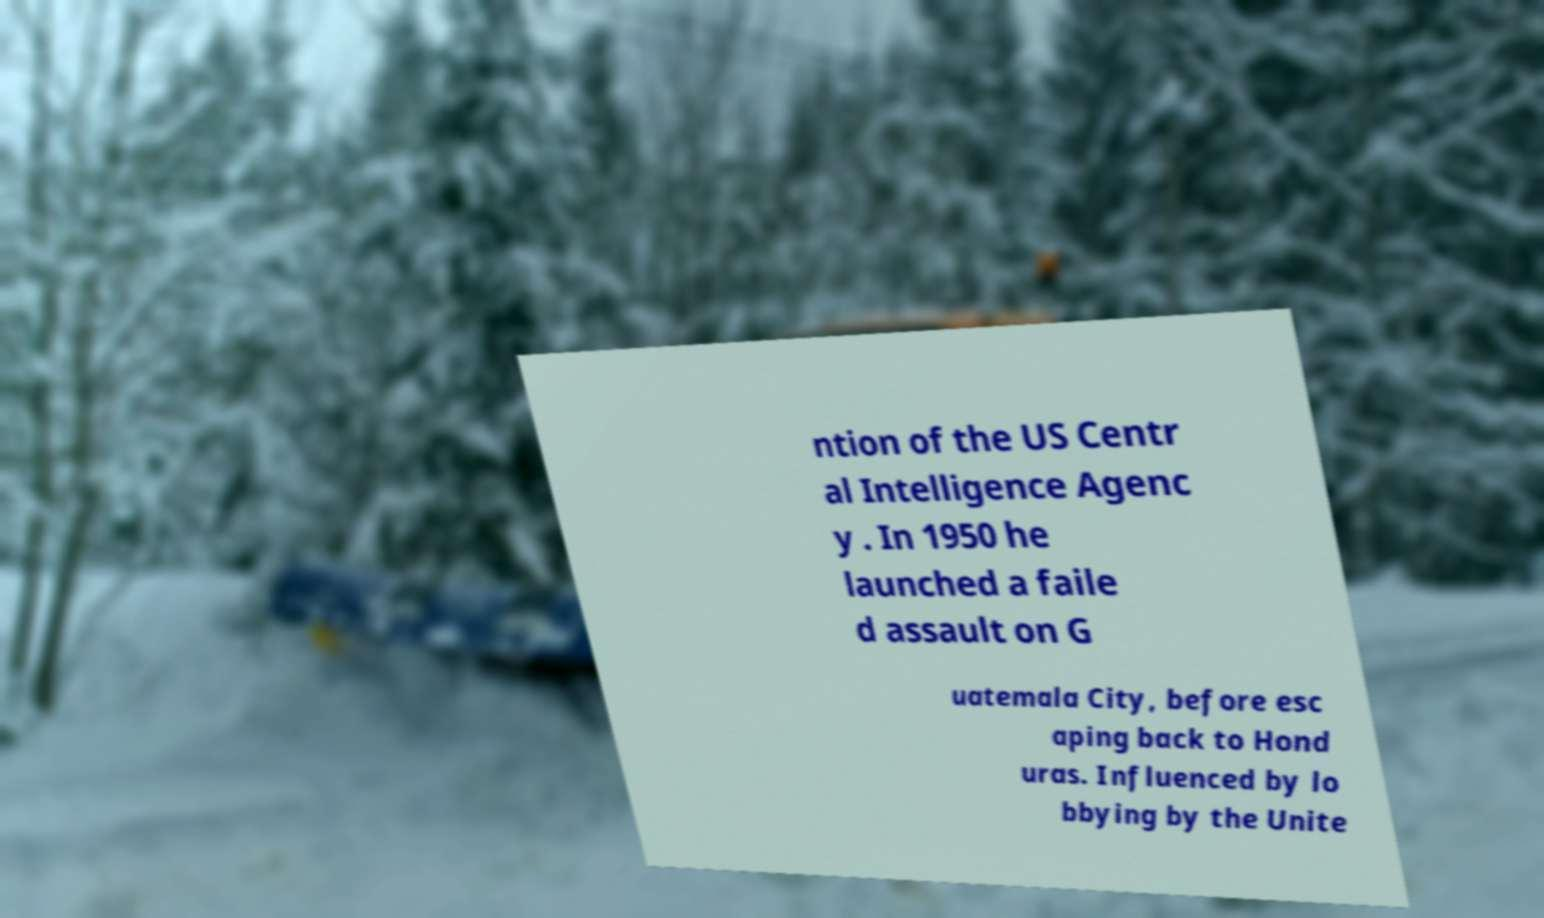What messages or text are displayed in this image? I need them in a readable, typed format. ntion of the US Centr al Intelligence Agenc y . In 1950 he launched a faile d assault on G uatemala City, before esc aping back to Hond uras. Influenced by lo bbying by the Unite 